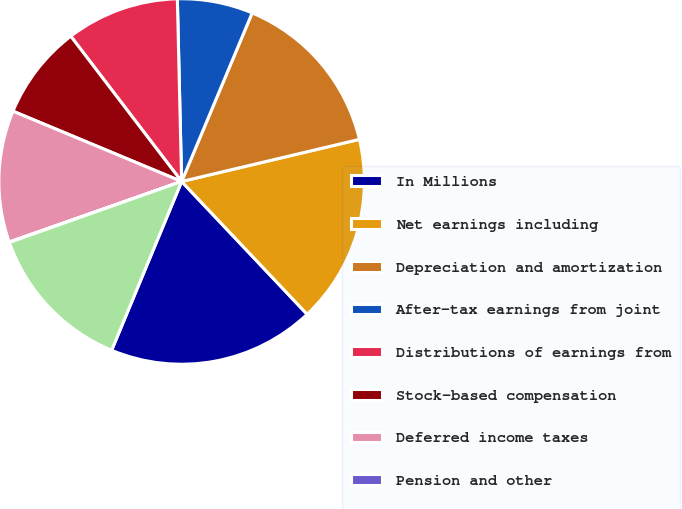Convert chart. <chart><loc_0><loc_0><loc_500><loc_500><pie_chart><fcel>In Millions<fcel>Net earnings including<fcel>Depreciation and amortization<fcel>After-tax earnings from joint<fcel>Distributions of earnings from<fcel>Stock-based compensation<fcel>Deferred income taxes<fcel>Pension and other<fcel>Restructuring impairment and<nl><fcel>18.31%<fcel>16.65%<fcel>14.99%<fcel>6.68%<fcel>10.0%<fcel>8.34%<fcel>11.66%<fcel>0.04%<fcel>13.33%<nl></chart> 